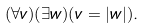Convert formula to latex. <formula><loc_0><loc_0><loc_500><loc_500>( \forall v ) ( \exists w ) ( v = | w | ) .</formula> 